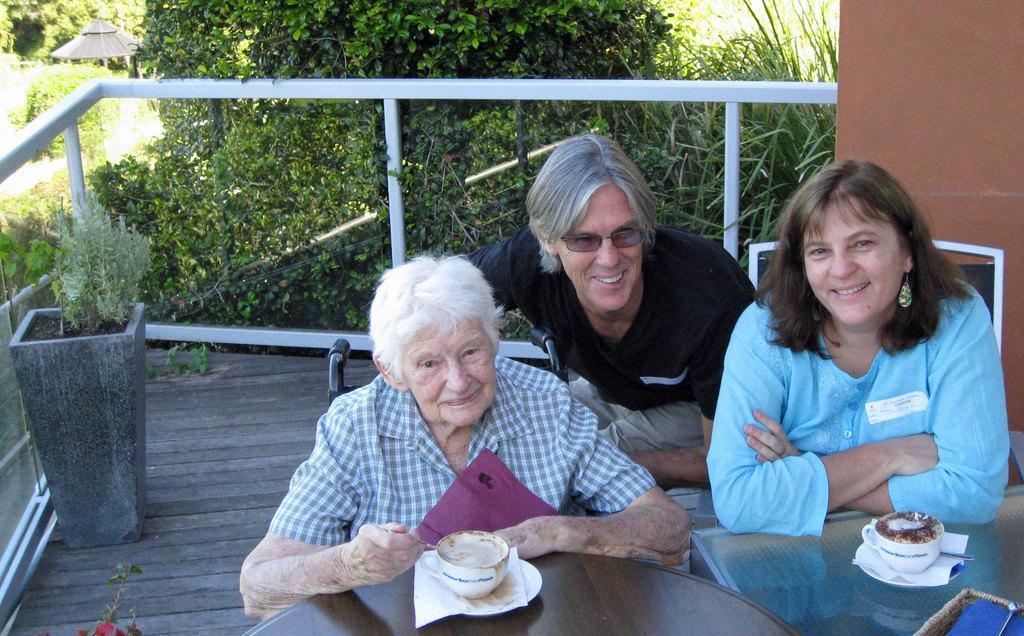Could you give a brief overview of what you see in this image? There are three persons sitting on chairs and this woman holding spoon and we can see cups,saucers and tissue papers on tables. On the background we can see trees,plant and wall. 